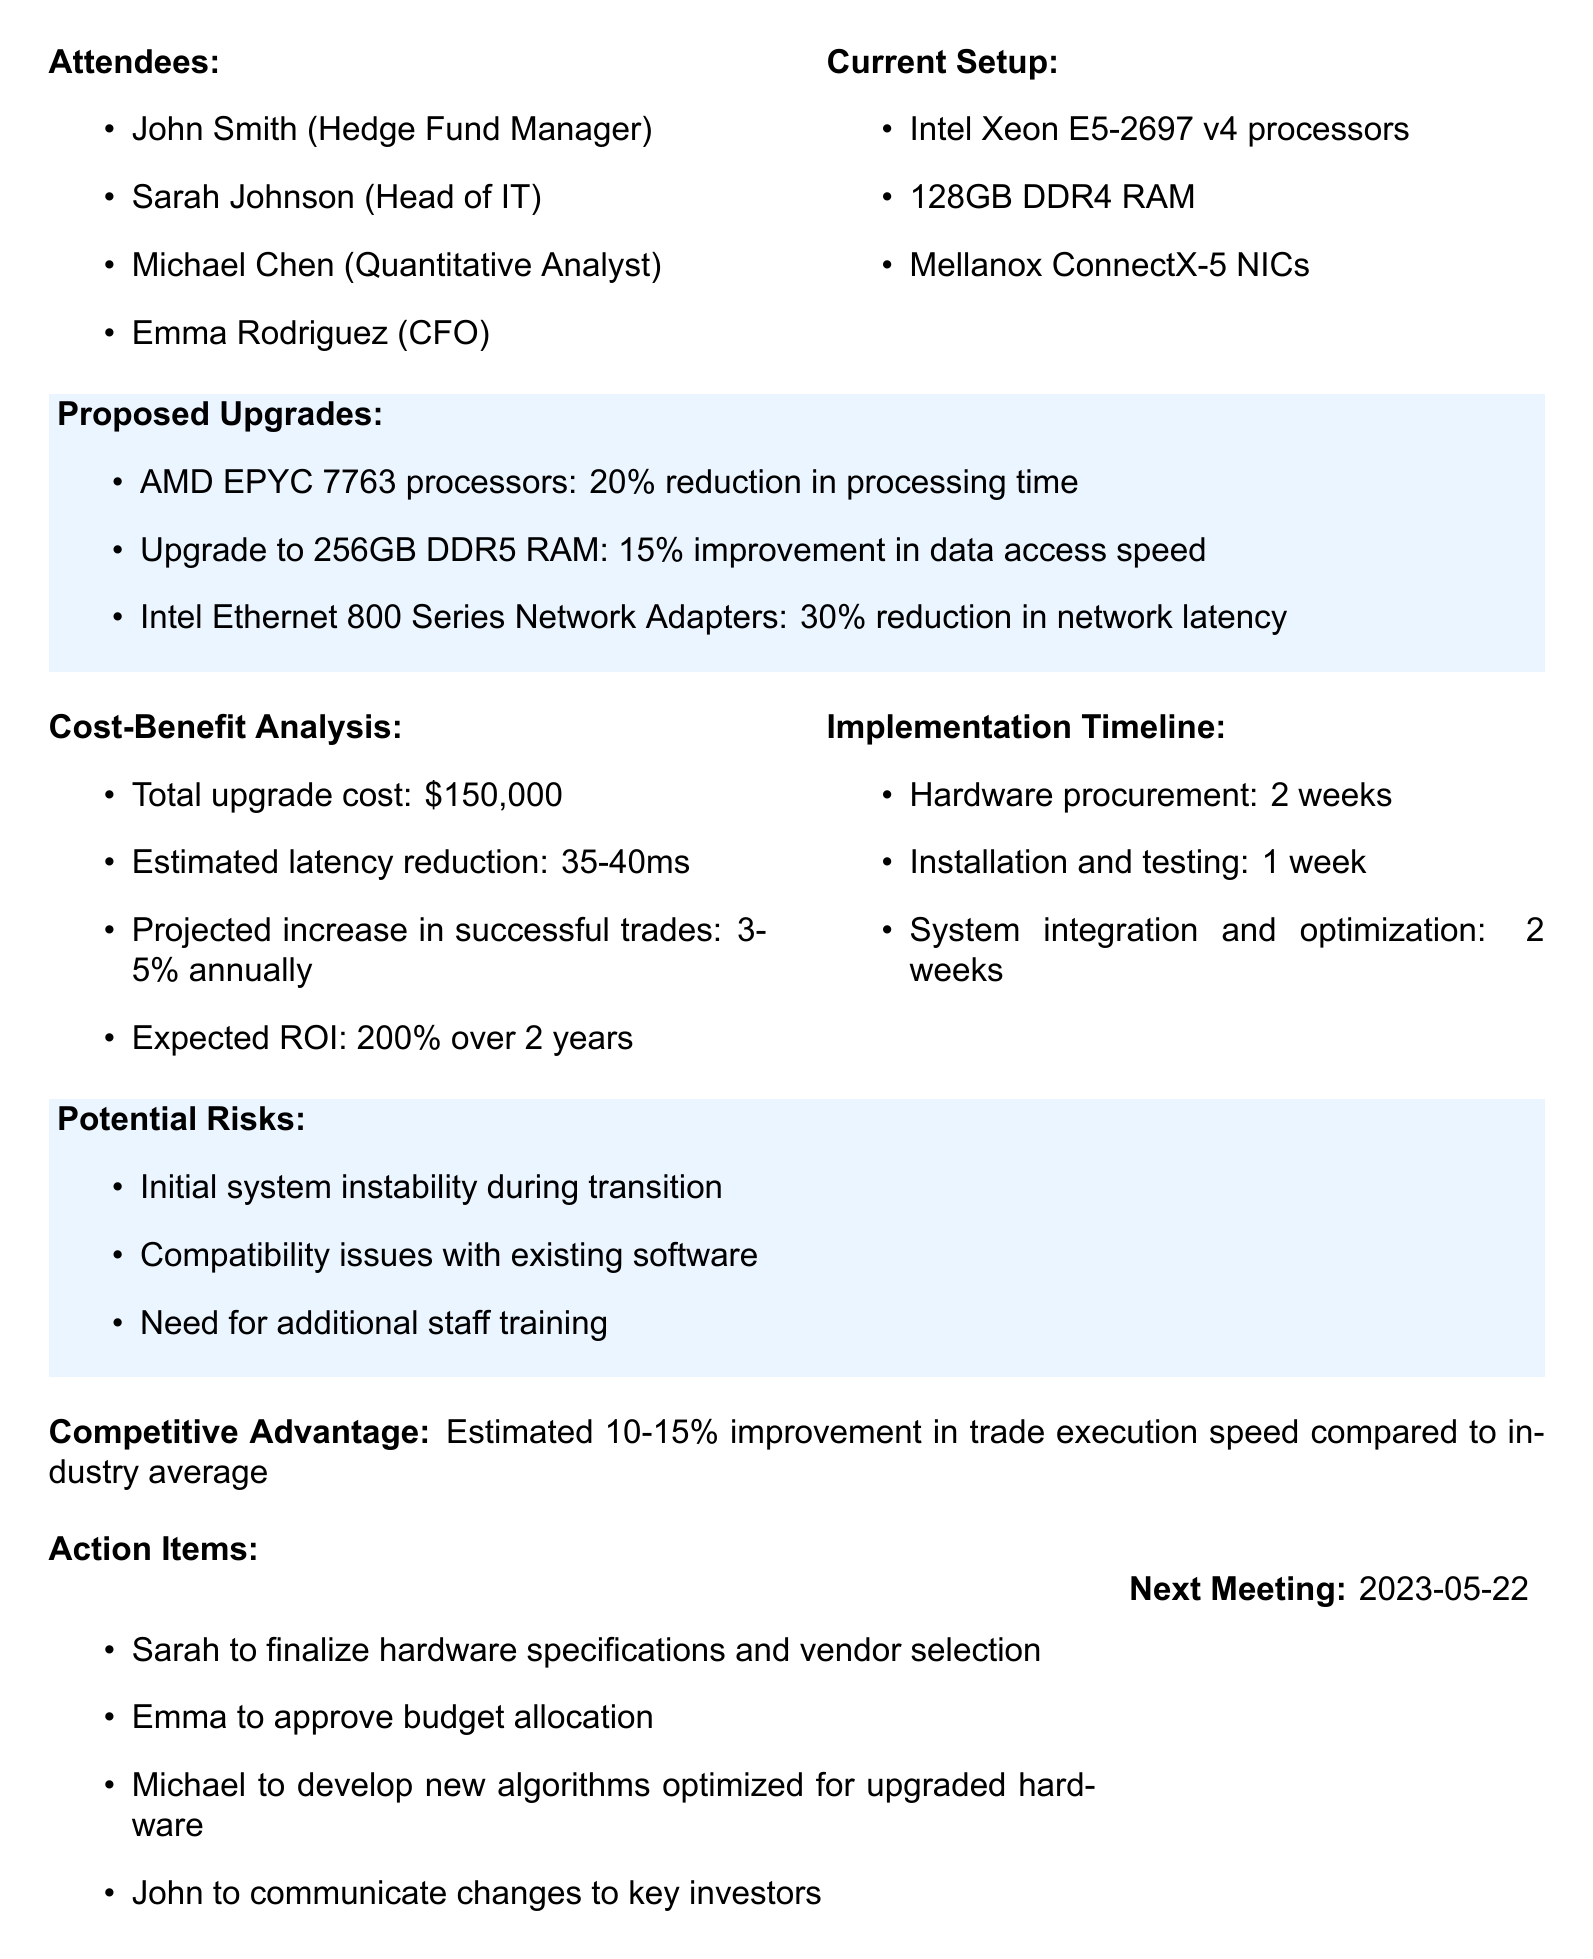What are the names of the attendees? The attendees are listed in the document under the "attendees" section.
Answer: John Smith, Sarah Johnson, Michael Chen, Emma Rodriguez What is the total upgrade cost? The document provides the total upgrade cost under the "Cost-Benefit Analysis" section.
Answer: $150,000 What processors are currently in use? The current hardware setup is specified in the document.
Answer: Intel Xeon E5-2697 v4 processors What is the expected ROI over 2 years? The expected ROI can be found in the "Cost-Benefit Analysis" section of the document.
Answer: 200% What is the projected increase in successful trades annually? This information is stated in the "Cost-Benefit Analysis" section.
Answer: 3-5% annually What is the estimated improvement in trade execution speed compared to the industry average? This is mentioned in the "Competitive Advantage" section of the document.
Answer: 10-15% What is the time frame for hardware procurement? The implementation timeline shows how long hardware procurement will take.
Answer: 2 weeks What are potential risks identified in the meeting? The potential risks are listed in the "Potential Risks" section.
Answer: Initial system instability, compatibility issues, additional staff training Who is responsible for developing new algorithms? The action items specify who will develop the new algorithms.
Answer: Michael 